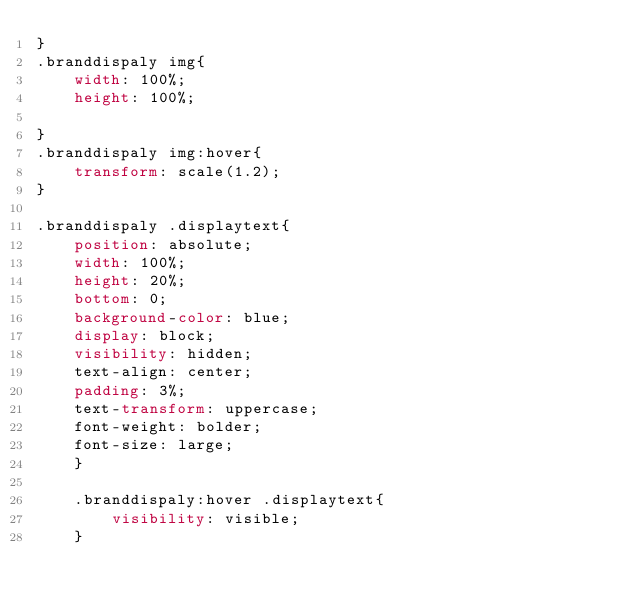<code> <loc_0><loc_0><loc_500><loc_500><_CSS_>}
.branddispaly img{
    width: 100%;
    height: 100%;
   
}
.branddispaly img:hover{
    transform: scale(1.2);
}

.branddispaly .displaytext{
    position: absolute;
    width: 100%;
    height: 20%;
    bottom: 0;
    background-color: blue;
    display: block;
    visibility: hidden;
    text-align: center;
    padding: 3%;
    text-transform: uppercase;
    font-weight: bolder;
    font-size: large;
    }

    .branddispaly:hover .displaytext{
        visibility: visible;
    }</code> 